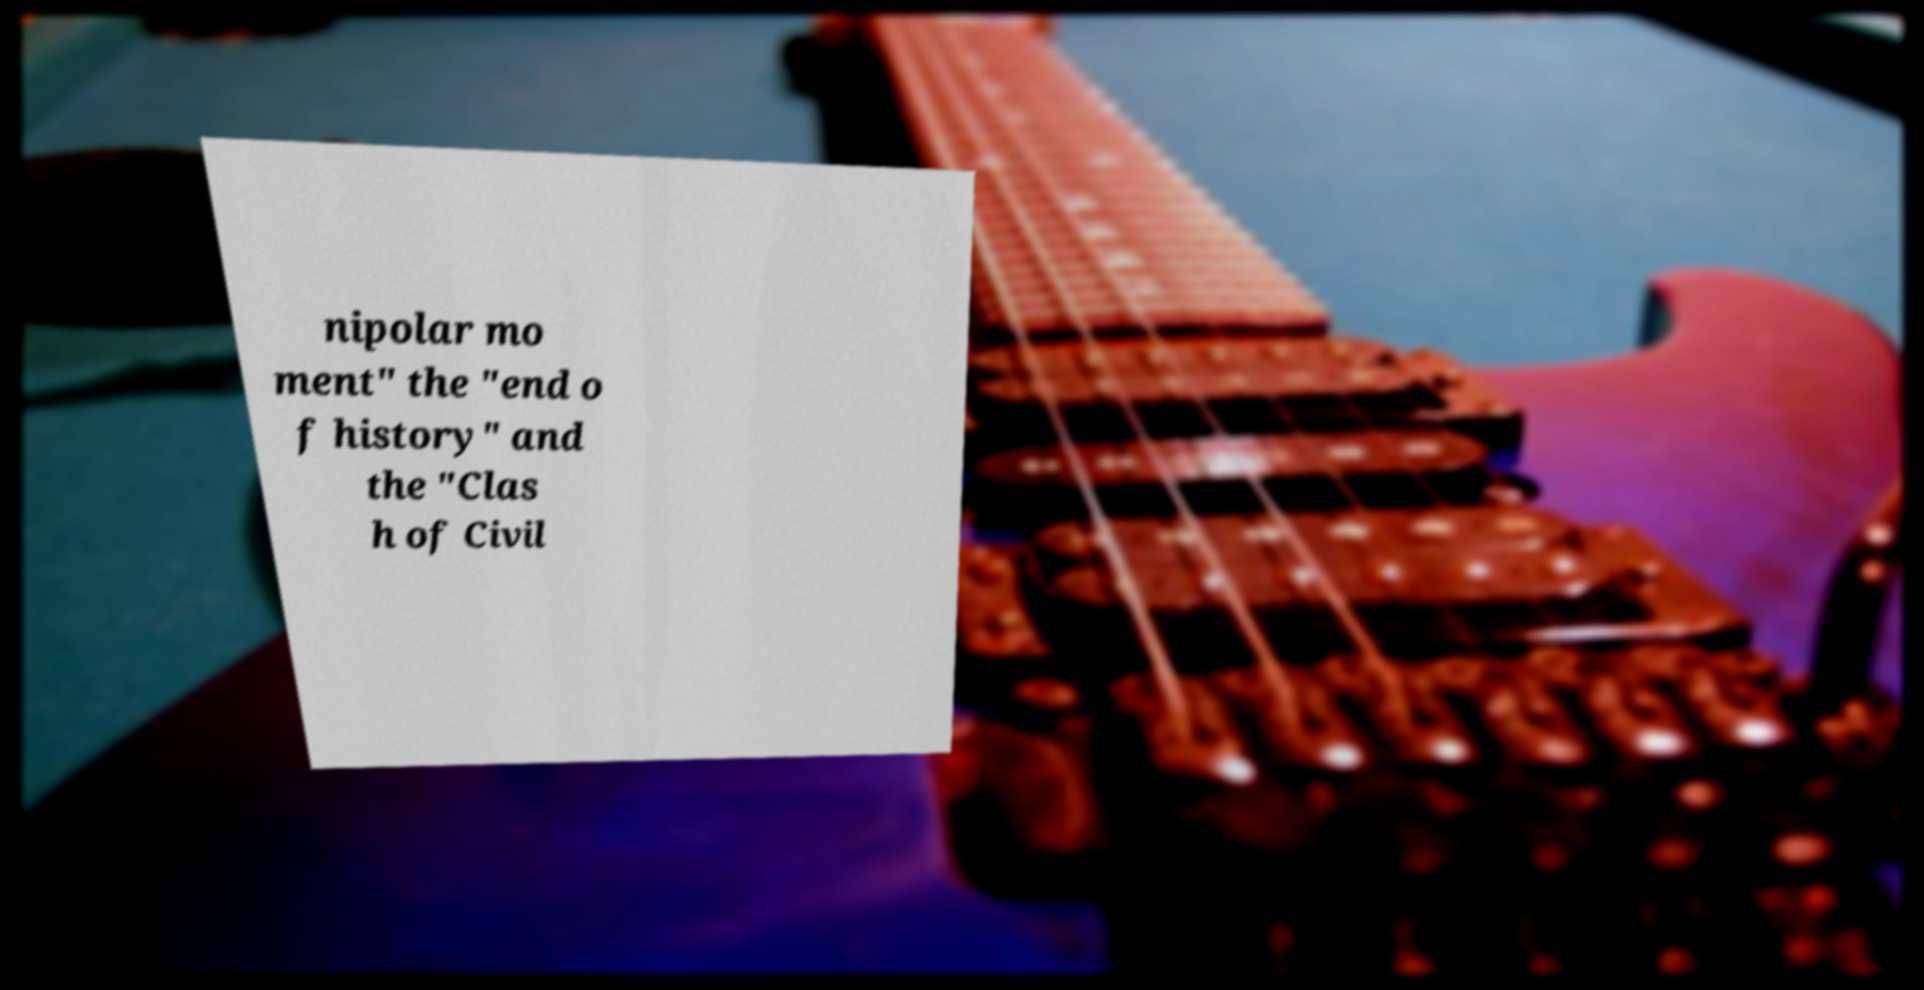For documentation purposes, I need the text within this image transcribed. Could you provide that? nipolar mo ment" the "end o f history" and the "Clas h of Civil 